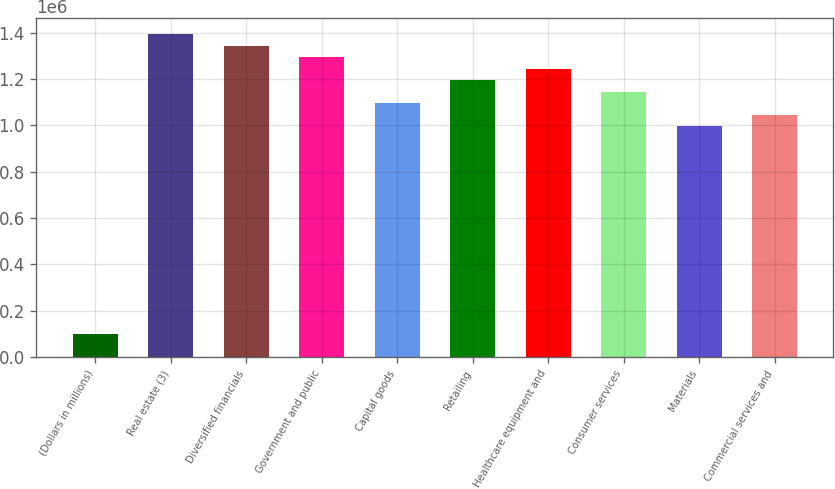<chart> <loc_0><loc_0><loc_500><loc_500><bar_chart><fcel>(Dollars in millions)<fcel>Real estate (3)<fcel>Diversified financials<fcel>Government and public<fcel>Capital goods<fcel>Retailing<fcel>Healthcare equipment and<fcel>Consumer services<fcel>Materials<fcel>Commercial services and<nl><fcel>100634<fcel>1.39451e+06<fcel>1.34474e+06<fcel>1.29498e+06<fcel>1.09592e+06<fcel>1.19545e+06<fcel>1.24522e+06<fcel>1.14569e+06<fcel>996393<fcel>1.04616e+06<nl></chart> 